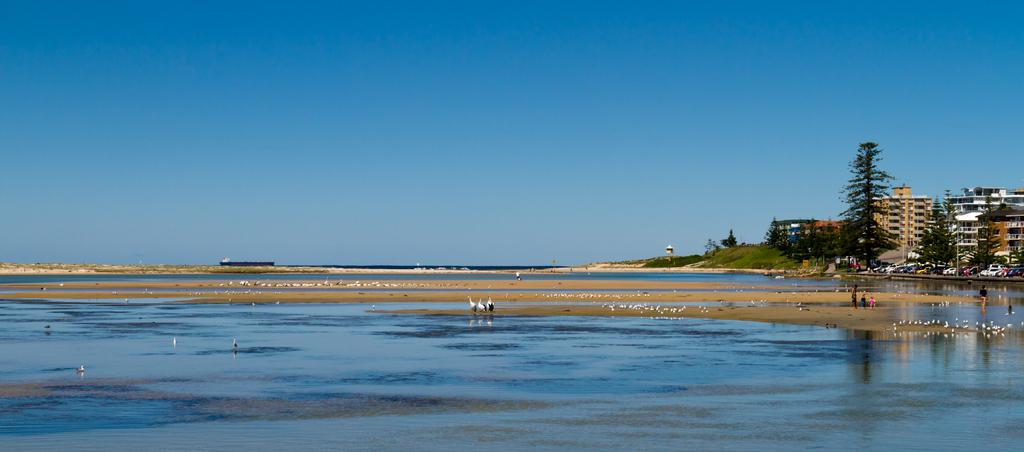What is located in the center of the image? There are birds in the center of the image. What can be seen in the image besides the birds? There is water visible in the image, as well as buildings and trees on the right side of the image. What is visible at the top of the image? The sky is visible at the top of the image. What type of jeans can be seen on the visitor in the image? There is no visitor or jeans present in the image. What smell can be detected in the image? The image does not convey any smells, as it is a visual medium. 